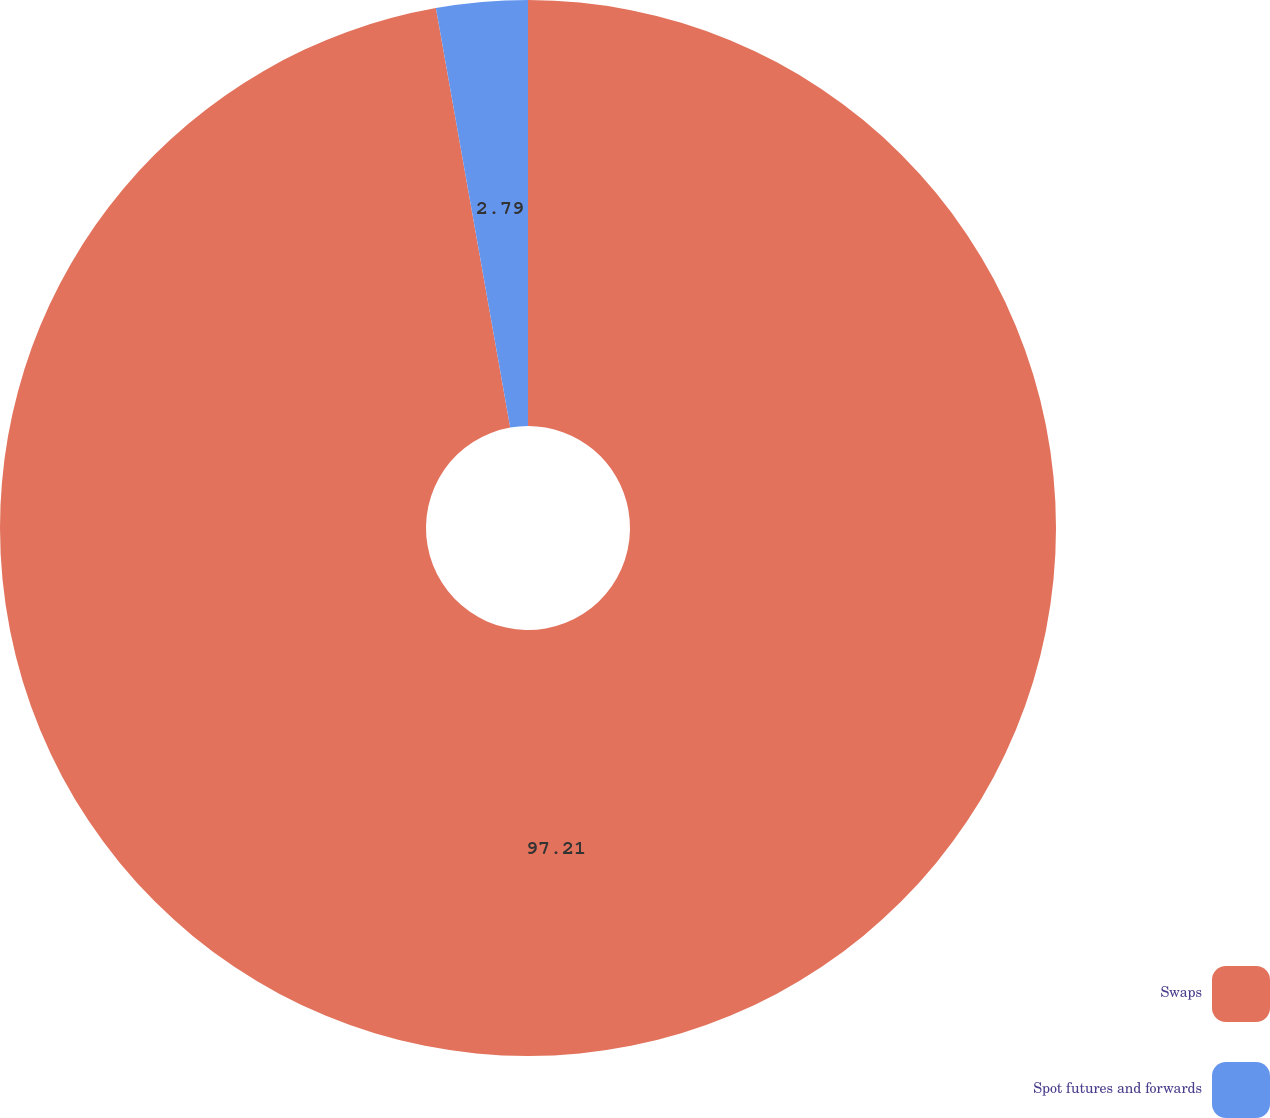Convert chart. <chart><loc_0><loc_0><loc_500><loc_500><pie_chart><fcel>Swaps<fcel>Spot futures and forwards<nl><fcel>97.21%<fcel>2.79%<nl></chart> 